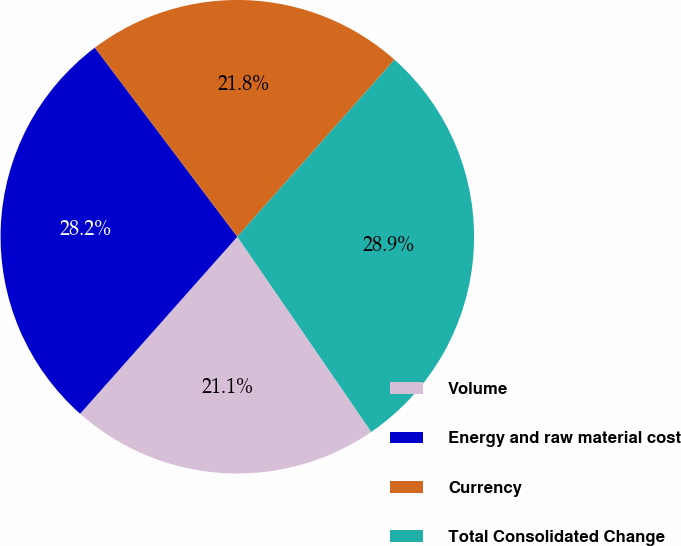Convert chart to OTSL. <chart><loc_0><loc_0><loc_500><loc_500><pie_chart><fcel>Volume<fcel>Energy and raw material cost<fcel>Currency<fcel>Total Consolidated Change<nl><fcel>21.13%<fcel>28.17%<fcel>21.83%<fcel>28.87%<nl></chart> 